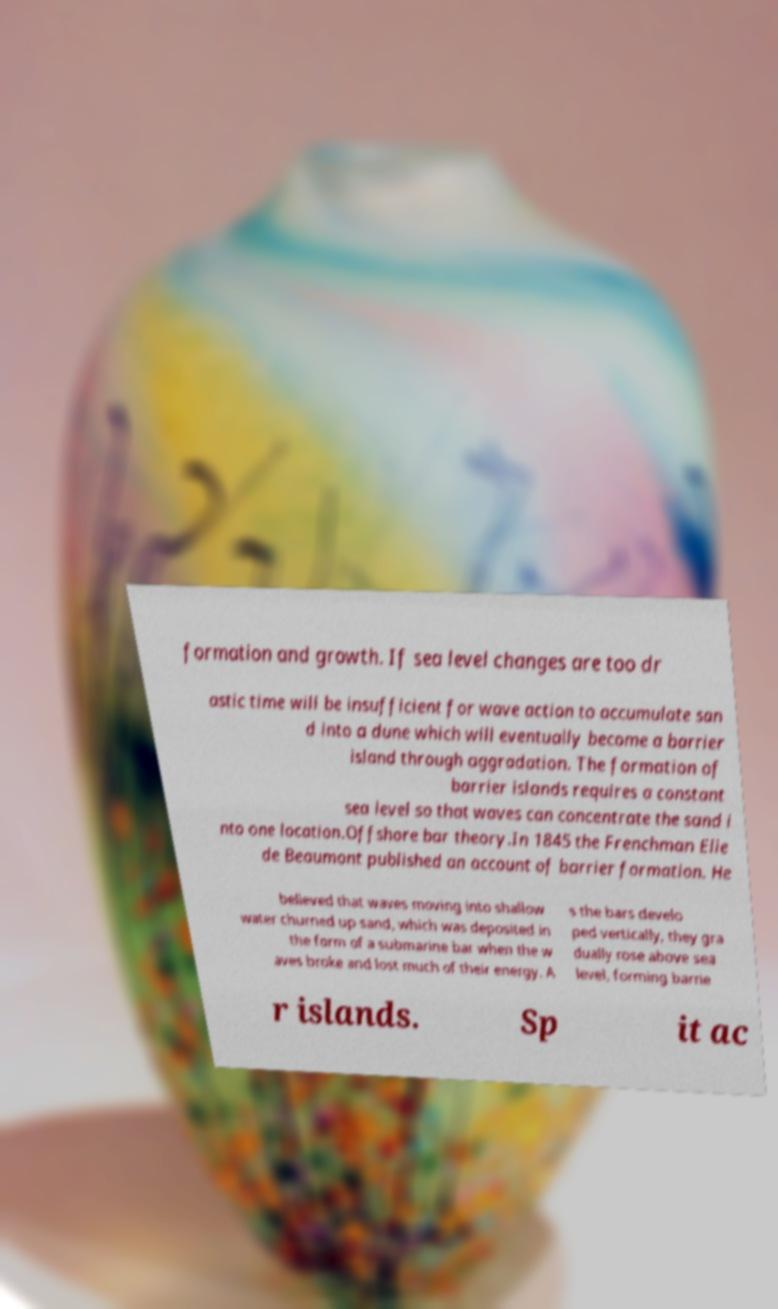For documentation purposes, I need the text within this image transcribed. Could you provide that? formation and growth. If sea level changes are too dr astic time will be insufficient for wave action to accumulate san d into a dune which will eventually become a barrier island through aggradation. The formation of barrier islands requires a constant sea level so that waves can concentrate the sand i nto one location.Offshore bar theory.In 1845 the Frenchman Elie de Beaumont published an account of barrier formation. He believed that waves moving into shallow water churned up sand, which was deposited in the form of a submarine bar when the w aves broke and lost much of their energy. A s the bars develo ped vertically, they gra dually rose above sea level, forming barrie r islands. Sp it ac 